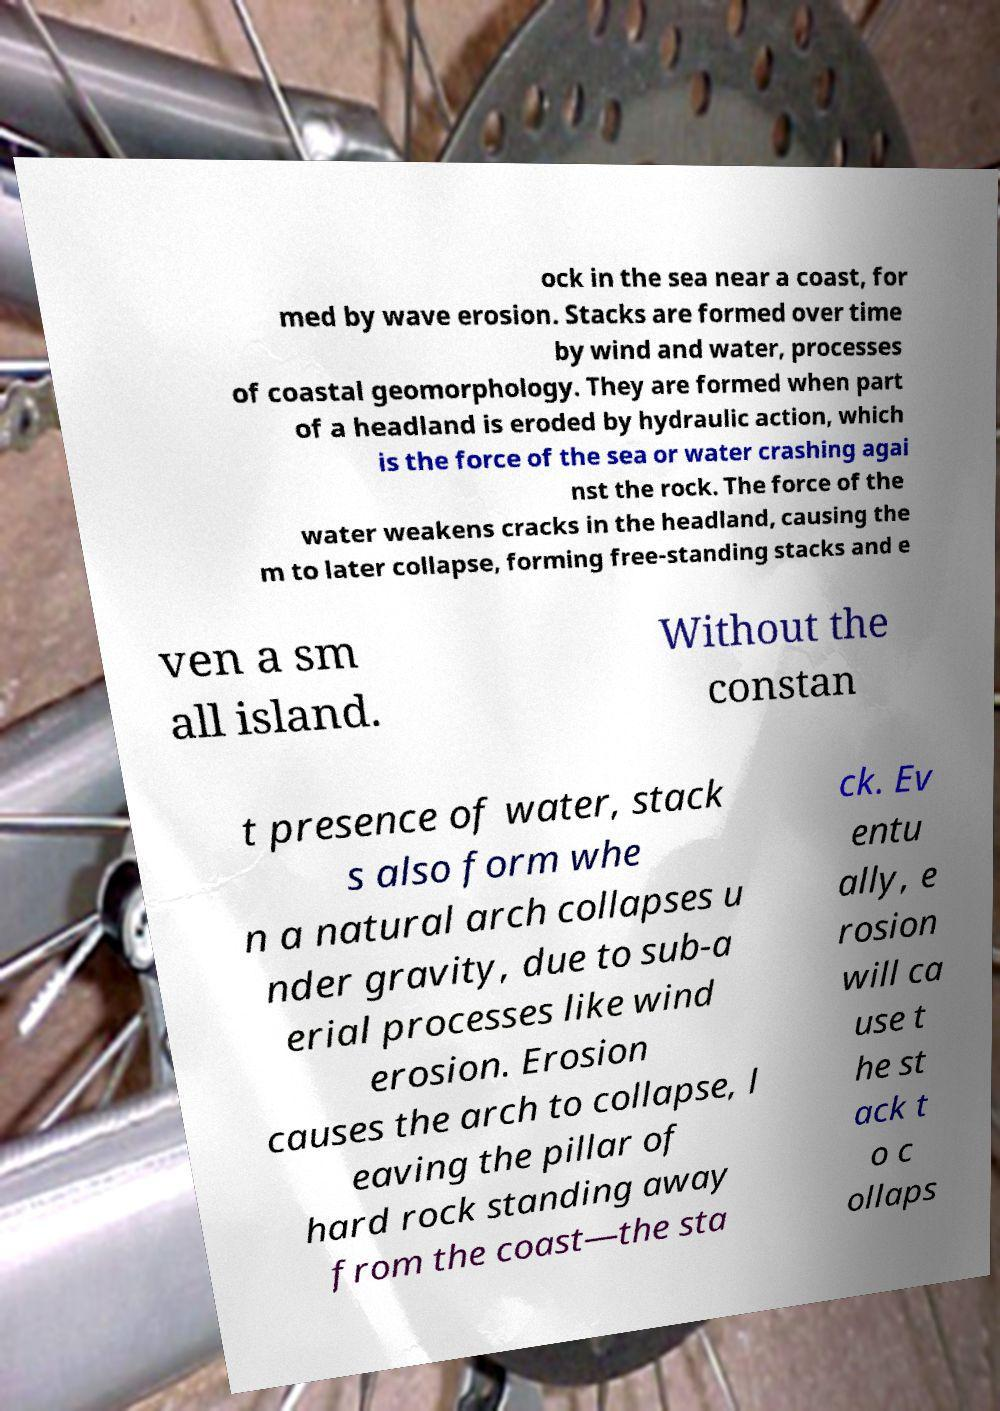For documentation purposes, I need the text within this image transcribed. Could you provide that? ock in the sea near a coast, for med by wave erosion. Stacks are formed over time by wind and water, processes of coastal geomorphology. They are formed when part of a headland is eroded by hydraulic action, which is the force of the sea or water crashing agai nst the rock. The force of the water weakens cracks in the headland, causing the m to later collapse, forming free-standing stacks and e ven a sm all island. Without the constan t presence of water, stack s also form whe n a natural arch collapses u nder gravity, due to sub-a erial processes like wind erosion. Erosion causes the arch to collapse, l eaving the pillar of hard rock standing away from the coast—the sta ck. Ev entu ally, e rosion will ca use t he st ack t o c ollaps 